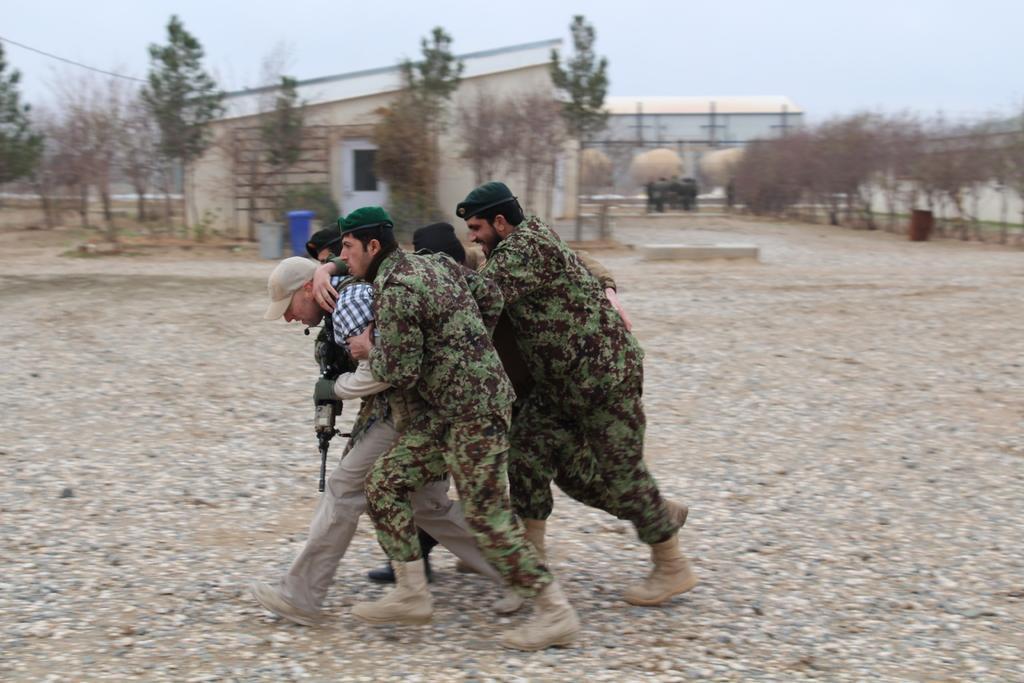Describe this image in one or two sentences. In this image there are a few people walking on the surface. In the background there are buildings, trees and the sky. 